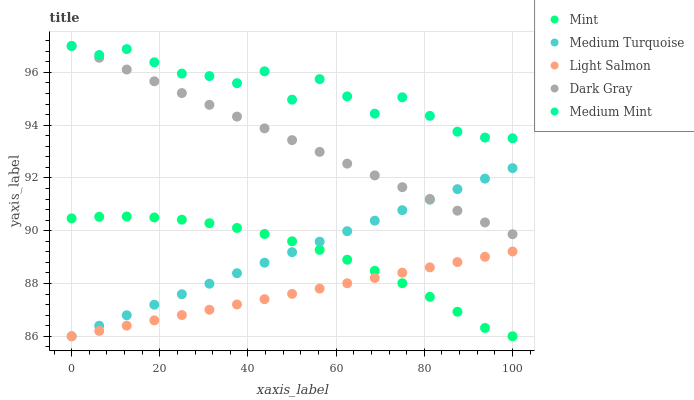Does Light Salmon have the minimum area under the curve?
Answer yes or no. Yes. Does Medium Mint have the maximum area under the curve?
Answer yes or no. Yes. Does Medium Mint have the minimum area under the curve?
Answer yes or no. No. Does Light Salmon have the maximum area under the curve?
Answer yes or no. No. Is Light Salmon the smoothest?
Answer yes or no. Yes. Is Medium Mint the roughest?
Answer yes or no. Yes. Is Medium Mint the smoothest?
Answer yes or no. No. Is Light Salmon the roughest?
Answer yes or no. No. Does Light Salmon have the lowest value?
Answer yes or no. Yes. Does Medium Mint have the lowest value?
Answer yes or no. No. Does Medium Mint have the highest value?
Answer yes or no. Yes. Does Light Salmon have the highest value?
Answer yes or no. No. Is Mint less than Dark Gray?
Answer yes or no. Yes. Is Medium Mint greater than Light Salmon?
Answer yes or no. Yes. Does Dark Gray intersect Medium Turquoise?
Answer yes or no. Yes. Is Dark Gray less than Medium Turquoise?
Answer yes or no. No. Is Dark Gray greater than Medium Turquoise?
Answer yes or no. No. Does Mint intersect Dark Gray?
Answer yes or no. No. 